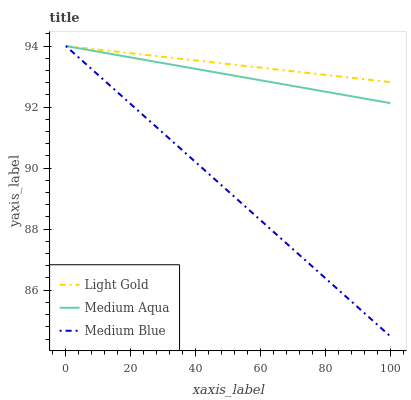Does Medium Blue have the minimum area under the curve?
Answer yes or no. Yes. Does Light Gold have the maximum area under the curve?
Answer yes or no. Yes. Does Light Gold have the minimum area under the curve?
Answer yes or no. No. Does Medium Blue have the maximum area under the curve?
Answer yes or no. No. Is Medium Aqua the smoothest?
Answer yes or no. Yes. Is Medium Blue the roughest?
Answer yes or no. Yes. Is Light Gold the smoothest?
Answer yes or no. No. Is Light Gold the roughest?
Answer yes or no. No. Does Medium Blue have the lowest value?
Answer yes or no. Yes. Does Light Gold have the lowest value?
Answer yes or no. No. Does Medium Blue have the highest value?
Answer yes or no. Yes. Does Medium Aqua intersect Light Gold?
Answer yes or no. Yes. Is Medium Aqua less than Light Gold?
Answer yes or no. No. Is Medium Aqua greater than Light Gold?
Answer yes or no. No. 